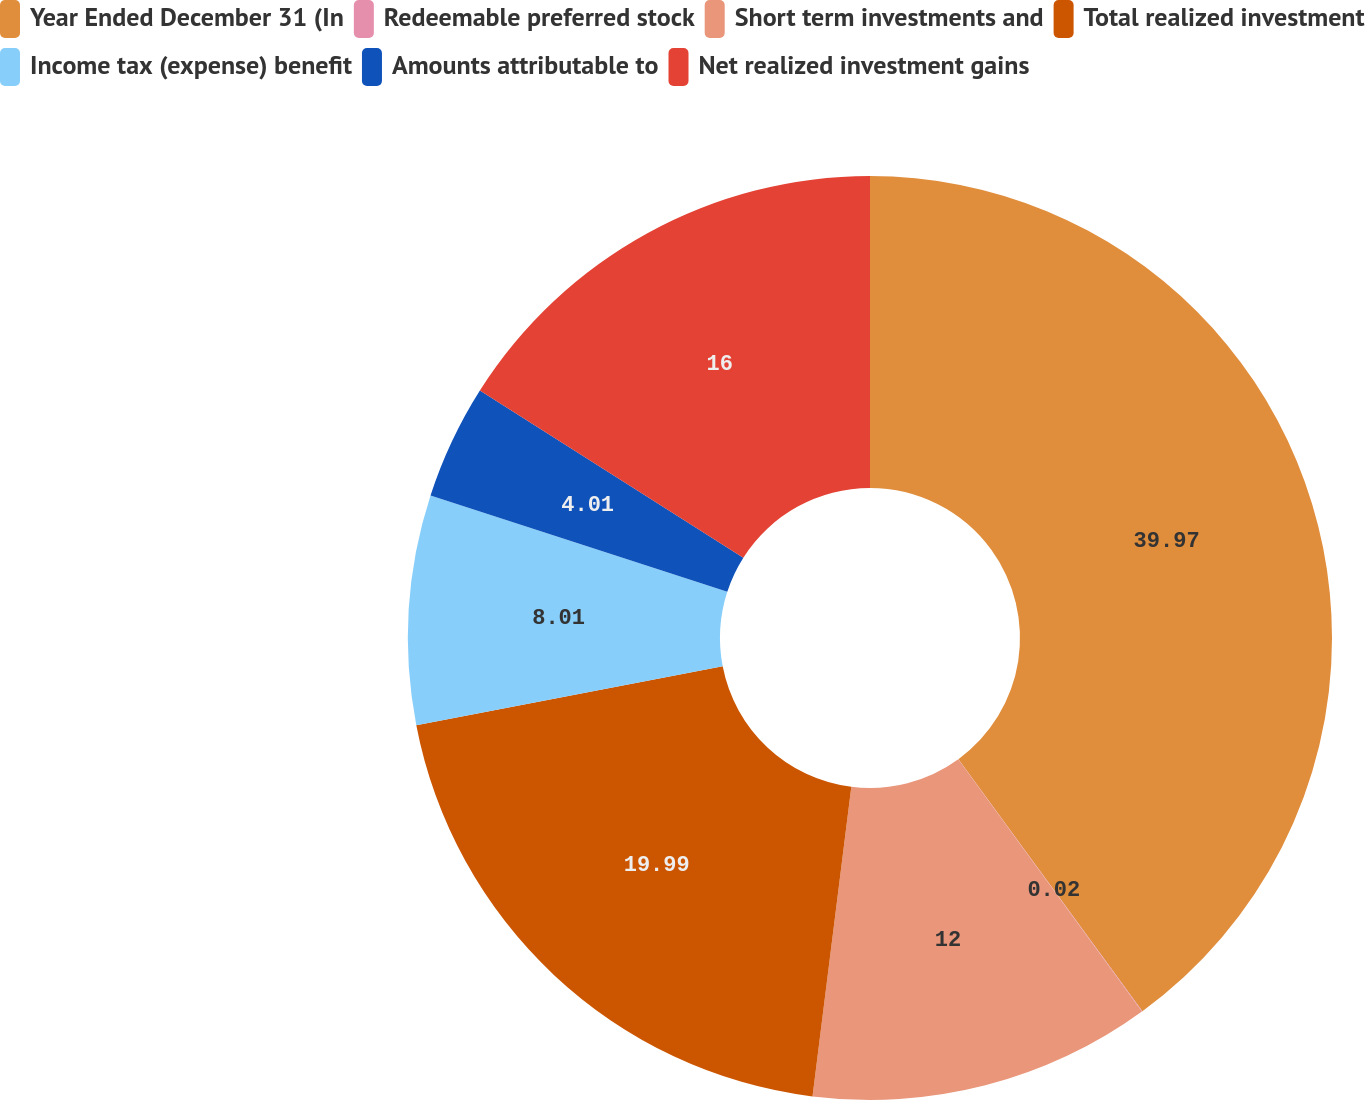Convert chart. <chart><loc_0><loc_0><loc_500><loc_500><pie_chart><fcel>Year Ended December 31 (In<fcel>Redeemable preferred stock<fcel>Short term investments and<fcel>Total realized investment<fcel>Income tax (expense) benefit<fcel>Amounts attributable to<fcel>Net realized investment gains<nl><fcel>39.96%<fcel>0.02%<fcel>12.0%<fcel>19.99%<fcel>8.01%<fcel>4.01%<fcel>16.0%<nl></chart> 